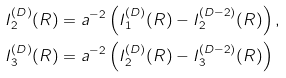<formula> <loc_0><loc_0><loc_500><loc_500>I _ { 2 } ^ { ( D ) } ( R ) & = a ^ { - 2 } \left ( I _ { 1 } ^ { ( D ) } ( R ) - I _ { 2 } ^ { ( D - 2 ) } ( R ) \right ) , \\ I _ { 3 } ^ { ( D ) } ( R ) & = a ^ { - 2 } \left ( I _ { 2 } ^ { ( D ) } ( R ) - I _ { 3 } ^ { ( D - 2 ) } ( R ) \right )</formula> 